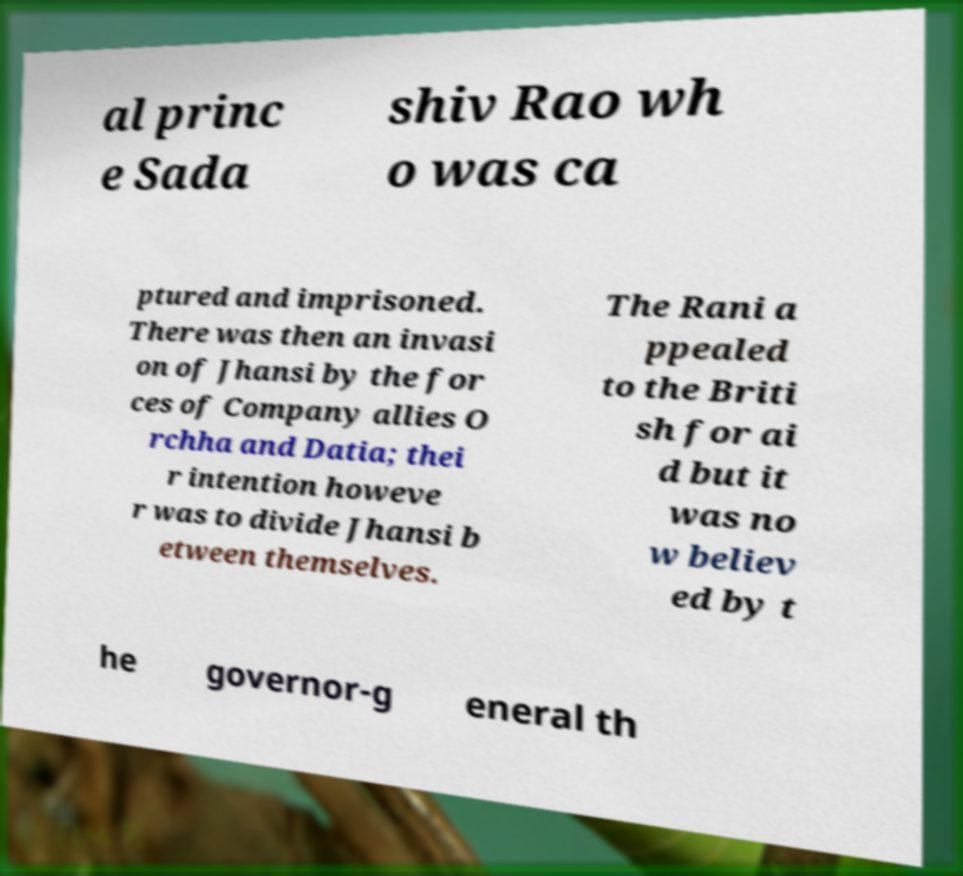What messages or text are displayed in this image? I need them in a readable, typed format. al princ e Sada shiv Rao wh o was ca ptured and imprisoned. There was then an invasi on of Jhansi by the for ces of Company allies O rchha and Datia; thei r intention howeve r was to divide Jhansi b etween themselves. The Rani a ppealed to the Briti sh for ai d but it was no w believ ed by t he governor-g eneral th 